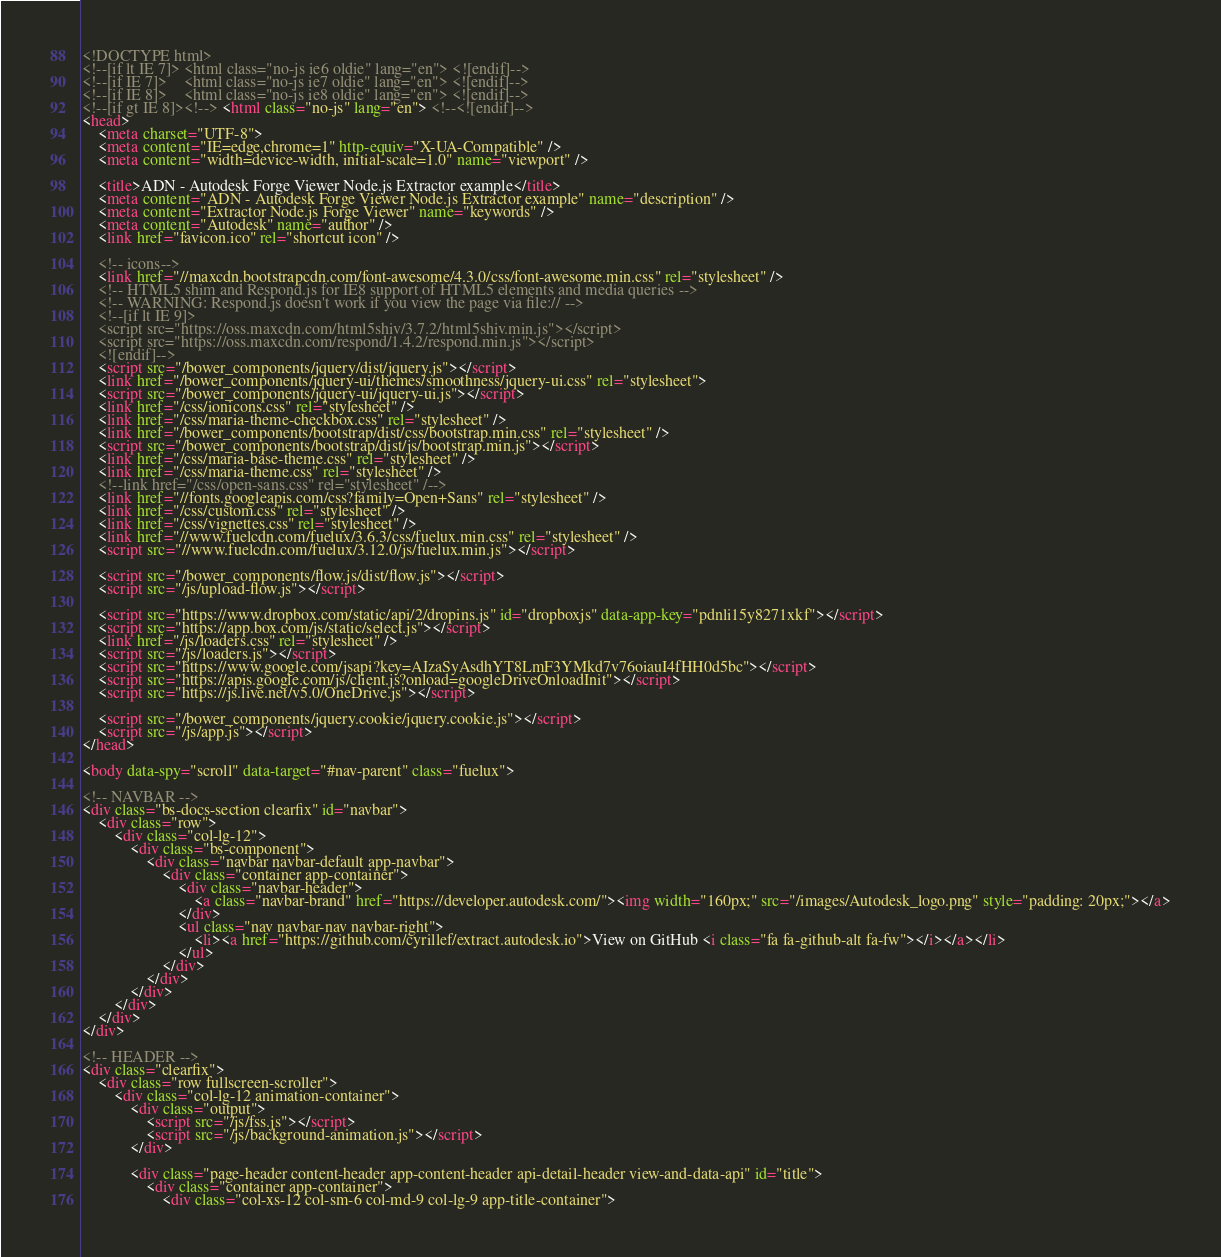<code> <loc_0><loc_0><loc_500><loc_500><_HTML_><!DOCTYPE html>
<!--[if lt IE 7]> <html class="no-js ie6 oldie" lang="en"> <![endif]-->
<!--[if IE 7]>    <html class="no-js ie7 oldie" lang="en"> <![endif]-->
<!--[if IE 8]>    <html class="no-js ie8 oldie" lang="en"> <![endif]-->
<!--[if gt IE 8]><!--> <html class="no-js" lang="en"> <!--<![endif]-->
<head>
    <meta charset="UTF-8">
    <meta content="IE=edge,chrome=1" http-equiv="X-UA-Compatible" />
    <meta content="width=device-width, initial-scale=1.0" name="viewport" />

    <title>ADN - Autodesk Forge Viewer Node.js Extractor example</title>
    <meta content="ADN - Autodesk Forge Viewer Node.js Extractor example" name="description" />
    <meta content="Extractor Node.js Forge Viewer" name="keywords" />
    <meta content="Autodesk" name="author" />
    <link href="favicon.ico" rel="shortcut icon" />

    <!-- icons-->
    <link href="//maxcdn.bootstrapcdn.com/font-awesome/4.3.0/css/font-awesome.min.css" rel="stylesheet" />
    <!-- HTML5 shim and Respond.js for IE8 support of HTML5 elements and media queries -->
    <!-- WARNING: Respond.js doesn't work if you view the page via file:// -->
    <!--[if lt IE 9]>
    <script src="https://oss.maxcdn.com/html5shiv/3.7.2/html5shiv.min.js"></script>
    <script src="https://oss.maxcdn.com/respond/1.4.2/respond.min.js"></script>
    <![endif]-->
    <script src="/bower_components/jquery/dist/jquery.js"></script>
    <link href="/bower_components/jquery-ui/themes/smoothness/jquery-ui.css" rel="stylesheet">
    <script src="/bower_components/jquery-ui/jquery-ui.js"></script>
    <link href="/css/ionicons.css" rel="stylesheet" />
    <link href="/css/maria-theme-checkbox.css" rel="stylesheet" />
    <link href="/bower_components/bootstrap/dist/css/bootstrap.min.css" rel="stylesheet" />
    <script src="/bower_components/bootstrap/dist/js/bootstrap.min.js"></script>
    <link href="/css/maria-base-theme.css" rel="stylesheet" />
    <link href="/css/maria-theme.css" rel="stylesheet" />
    <!--link href="/css/open-sans.css" rel="stylesheet" /-->
    <link href="//fonts.googleapis.com/css?family=Open+Sans" rel="stylesheet" />
    <link href="/css/custom.css" rel="stylesheet" />
	<link href="/css/vignettes.css" rel="stylesheet" />
    <link href="//www.fuelcdn.com/fuelux/3.6.3/css/fuelux.min.css" rel="stylesheet" />
    <script src="//www.fuelcdn.com/fuelux/3.12.0/js/fuelux.min.js"></script>

    <script src="/bower_components/flow.js/dist/flow.js"></script>
    <script src="/js/upload-flow.js"></script>

    <script src="https://www.dropbox.com/static/api/2/dropins.js" id="dropboxjs" data-app-key="pdnli15y8271xkf"></script>
    <script src="https://app.box.com/js/static/select.js"></script>
    <link href="/js/loaders.css" rel="stylesheet" />
    <script src="/js/loaders.js"></script>
    <script src="https://www.google.com/jsapi?key=AIzaSyAsdhYT8LmF3YMkd7v76oiauI4fHH0d5bc"></script>
    <script src="https://apis.google.com/js/client.js?onload=googleDriveOnloadInit"></script>
    <script src="https://js.live.net/v5.0/OneDrive.js"></script>

	<script src="/bower_components/jquery.cookie/jquery.cookie.js"></script>
	<script src="/js/app.js"></script>
</head>

<body data-spy="scroll" data-target="#nav-parent" class="fuelux">

<!-- NAVBAR -->
<div class="bs-docs-section clearfix" id="navbar">
    <div class="row">
        <div class="col-lg-12">
            <div class="bs-component">
                <div class="navbar navbar-default app-navbar">
                    <div class="container app-container">
                        <div class="navbar-header">
                            <a class="navbar-brand" href="https://developer.autodesk.com/"><img width="160px;" src="/images/Autodesk_logo.png" style="padding: 20px;"></a>
                        </div>
                        <ul class="nav navbar-nav navbar-right">
                            <li><a href="https://github.com/cyrillef/extract.autodesk.io">View on GitHub <i class="fa fa-github-alt fa-fw"></i></a></li>
                        </ul>
                    </div>
                </div>
            </div>
        </div>
    </div>
</div>

<!-- HEADER -->
<div class="clearfix">
    <div class="row fullscreen-scroller">
        <div class="col-lg-12 animation-container">
            <div class="output">
                <script src="/js/fss.js"></script>
                <script src="/js/background-animation.js"></script>
            </div>

            <div class="page-header content-header app-content-header api-detail-header view-and-data-api" id="title">
                <div class="container app-container">
                    <div class="col-xs-12 col-sm-6 col-md-9 col-lg-9 app-title-container"></code> 